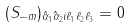<formula> <loc_0><loc_0><loc_500><loc_500>( S _ { - m } ) _ { { \hat { \alpha } } _ { 1 } { \hat { \alpha } } _ { 2 } i \ell _ { 1 } \ell _ { 2 } \ell _ { 3 } } = 0</formula> 